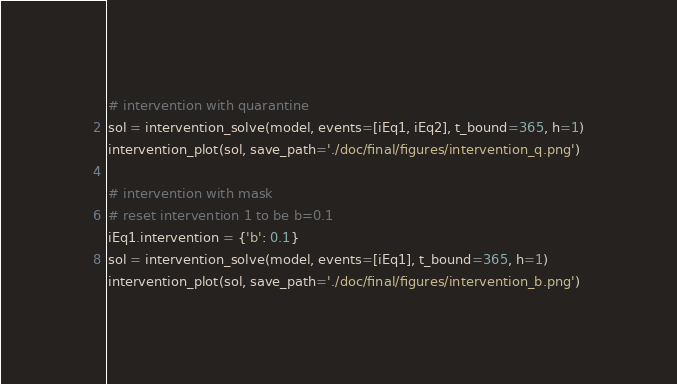<code> <loc_0><loc_0><loc_500><loc_500><_Python_>

# intervention with quarantine
sol = intervention_solve(model, events=[iEq1, iEq2], t_bound=365, h=1)
intervention_plot(sol, save_path='./doc/final/figures/intervention_q.png')

# intervention with mask
# reset intervention 1 to be b=0.1
iEq1.intervention = {'b': 0.1}
sol = intervention_solve(model, events=[iEq1], t_bound=365, h=1)
intervention_plot(sol, save_path='./doc/final/figures/intervention_b.png')
</code> 